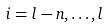<formula> <loc_0><loc_0><loc_500><loc_500>i = l - n , \dots , l</formula> 